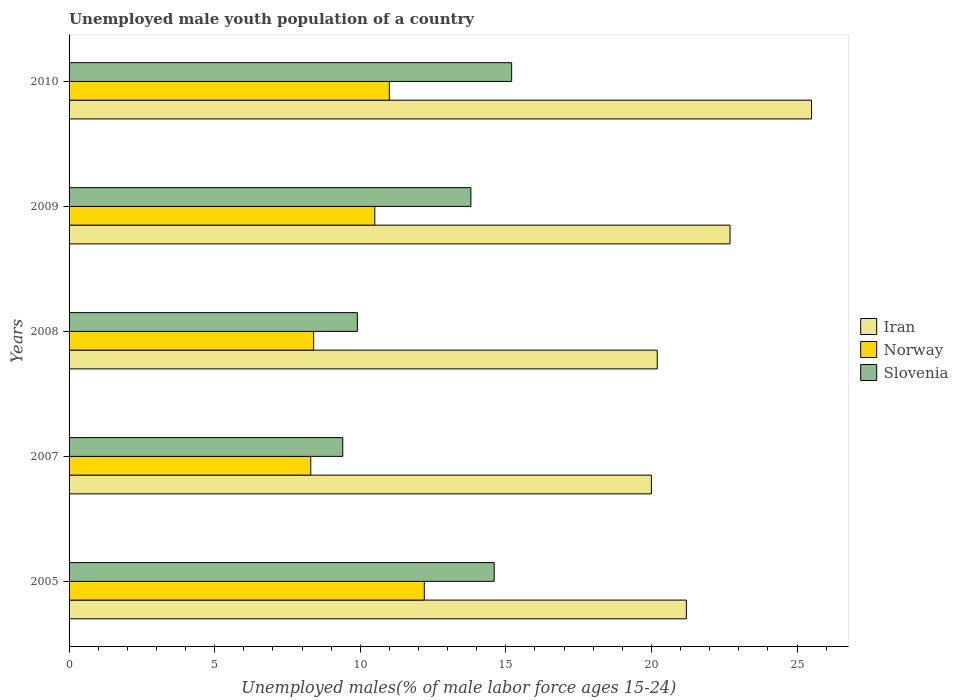How many different coloured bars are there?
Offer a very short reply. 3. How many groups of bars are there?
Provide a succinct answer. 5. Are the number of bars per tick equal to the number of legend labels?
Provide a succinct answer. Yes. How many bars are there on the 4th tick from the bottom?
Make the answer very short. 3. What is the percentage of unemployed male youth population in Iran in 2005?
Offer a very short reply. 21.2. Across all years, what is the maximum percentage of unemployed male youth population in Norway?
Offer a terse response. 12.2. Across all years, what is the minimum percentage of unemployed male youth population in Norway?
Offer a terse response. 8.3. In which year was the percentage of unemployed male youth population in Slovenia maximum?
Provide a short and direct response. 2010. In which year was the percentage of unemployed male youth population in Iran minimum?
Keep it short and to the point. 2007. What is the total percentage of unemployed male youth population in Norway in the graph?
Ensure brevity in your answer.  50.4. What is the difference between the percentage of unemployed male youth population in Slovenia in 2005 and that in 2009?
Ensure brevity in your answer.  0.8. What is the difference between the percentage of unemployed male youth population in Slovenia in 2008 and the percentage of unemployed male youth population in Norway in 2007?
Give a very brief answer. 1.6. What is the average percentage of unemployed male youth population in Slovenia per year?
Keep it short and to the point. 12.58. In the year 2010, what is the difference between the percentage of unemployed male youth population in Slovenia and percentage of unemployed male youth population in Iran?
Provide a short and direct response. -10.3. What is the ratio of the percentage of unemployed male youth population in Norway in 2007 to that in 2008?
Make the answer very short. 0.99. Is the difference between the percentage of unemployed male youth population in Slovenia in 2008 and 2009 greater than the difference between the percentage of unemployed male youth population in Iran in 2008 and 2009?
Your answer should be compact. No. What is the difference between the highest and the second highest percentage of unemployed male youth population in Norway?
Make the answer very short. 1.2. What is the difference between the highest and the lowest percentage of unemployed male youth population in Slovenia?
Keep it short and to the point. 5.8. In how many years, is the percentage of unemployed male youth population in Slovenia greater than the average percentage of unemployed male youth population in Slovenia taken over all years?
Ensure brevity in your answer.  3. What does the 3rd bar from the top in 2010 represents?
Keep it short and to the point. Iran. What does the 1st bar from the bottom in 2005 represents?
Provide a short and direct response. Iran. Is it the case that in every year, the sum of the percentage of unemployed male youth population in Norway and percentage of unemployed male youth population in Iran is greater than the percentage of unemployed male youth population in Slovenia?
Your response must be concise. Yes. What is the difference between two consecutive major ticks on the X-axis?
Your answer should be compact. 5. Are the values on the major ticks of X-axis written in scientific E-notation?
Your answer should be very brief. No. Does the graph contain any zero values?
Keep it short and to the point. No. How many legend labels are there?
Offer a very short reply. 3. How are the legend labels stacked?
Provide a succinct answer. Vertical. What is the title of the graph?
Provide a succinct answer. Unemployed male youth population of a country. What is the label or title of the X-axis?
Provide a succinct answer. Unemployed males(% of male labor force ages 15-24). What is the label or title of the Y-axis?
Your response must be concise. Years. What is the Unemployed males(% of male labor force ages 15-24) of Iran in 2005?
Make the answer very short. 21.2. What is the Unemployed males(% of male labor force ages 15-24) of Norway in 2005?
Make the answer very short. 12.2. What is the Unemployed males(% of male labor force ages 15-24) in Slovenia in 2005?
Give a very brief answer. 14.6. What is the Unemployed males(% of male labor force ages 15-24) in Iran in 2007?
Make the answer very short. 20. What is the Unemployed males(% of male labor force ages 15-24) of Norway in 2007?
Ensure brevity in your answer.  8.3. What is the Unemployed males(% of male labor force ages 15-24) in Slovenia in 2007?
Your response must be concise. 9.4. What is the Unemployed males(% of male labor force ages 15-24) of Iran in 2008?
Your answer should be compact. 20.2. What is the Unemployed males(% of male labor force ages 15-24) in Norway in 2008?
Keep it short and to the point. 8.4. What is the Unemployed males(% of male labor force ages 15-24) of Slovenia in 2008?
Ensure brevity in your answer.  9.9. What is the Unemployed males(% of male labor force ages 15-24) in Iran in 2009?
Offer a very short reply. 22.7. What is the Unemployed males(% of male labor force ages 15-24) in Norway in 2009?
Keep it short and to the point. 10.5. What is the Unemployed males(% of male labor force ages 15-24) in Slovenia in 2009?
Your response must be concise. 13.8. What is the Unemployed males(% of male labor force ages 15-24) of Norway in 2010?
Give a very brief answer. 11. What is the Unemployed males(% of male labor force ages 15-24) in Slovenia in 2010?
Give a very brief answer. 15.2. Across all years, what is the maximum Unemployed males(% of male labor force ages 15-24) in Iran?
Your response must be concise. 25.5. Across all years, what is the maximum Unemployed males(% of male labor force ages 15-24) in Norway?
Your answer should be compact. 12.2. Across all years, what is the maximum Unemployed males(% of male labor force ages 15-24) of Slovenia?
Your answer should be compact. 15.2. Across all years, what is the minimum Unemployed males(% of male labor force ages 15-24) of Norway?
Offer a terse response. 8.3. Across all years, what is the minimum Unemployed males(% of male labor force ages 15-24) in Slovenia?
Provide a short and direct response. 9.4. What is the total Unemployed males(% of male labor force ages 15-24) in Iran in the graph?
Keep it short and to the point. 109.6. What is the total Unemployed males(% of male labor force ages 15-24) in Norway in the graph?
Your response must be concise. 50.4. What is the total Unemployed males(% of male labor force ages 15-24) of Slovenia in the graph?
Your answer should be compact. 62.9. What is the difference between the Unemployed males(% of male labor force ages 15-24) in Iran in 2005 and that in 2007?
Make the answer very short. 1.2. What is the difference between the Unemployed males(% of male labor force ages 15-24) in Slovenia in 2005 and that in 2007?
Your response must be concise. 5.2. What is the difference between the Unemployed males(% of male labor force ages 15-24) in Norway in 2005 and that in 2008?
Ensure brevity in your answer.  3.8. What is the difference between the Unemployed males(% of male labor force ages 15-24) of Slovenia in 2005 and that in 2008?
Offer a very short reply. 4.7. What is the difference between the Unemployed males(% of male labor force ages 15-24) of Norway in 2005 and that in 2009?
Your response must be concise. 1.7. What is the difference between the Unemployed males(% of male labor force ages 15-24) of Iran in 2005 and that in 2010?
Provide a succinct answer. -4.3. What is the difference between the Unemployed males(% of male labor force ages 15-24) in Norway in 2005 and that in 2010?
Offer a very short reply. 1.2. What is the difference between the Unemployed males(% of male labor force ages 15-24) in Slovenia in 2005 and that in 2010?
Keep it short and to the point. -0.6. What is the difference between the Unemployed males(% of male labor force ages 15-24) of Slovenia in 2007 and that in 2008?
Ensure brevity in your answer.  -0.5. What is the difference between the Unemployed males(% of male labor force ages 15-24) of Slovenia in 2007 and that in 2009?
Your response must be concise. -4.4. What is the difference between the Unemployed males(% of male labor force ages 15-24) of Iran in 2007 and that in 2010?
Keep it short and to the point. -5.5. What is the difference between the Unemployed males(% of male labor force ages 15-24) of Norway in 2007 and that in 2010?
Keep it short and to the point. -2.7. What is the difference between the Unemployed males(% of male labor force ages 15-24) of Slovenia in 2007 and that in 2010?
Provide a succinct answer. -5.8. What is the difference between the Unemployed males(% of male labor force ages 15-24) of Norway in 2008 and that in 2009?
Give a very brief answer. -2.1. What is the difference between the Unemployed males(% of male labor force ages 15-24) in Slovenia in 2008 and that in 2009?
Provide a short and direct response. -3.9. What is the difference between the Unemployed males(% of male labor force ages 15-24) in Slovenia in 2009 and that in 2010?
Your response must be concise. -1.4. What is the difference between the Unemployed males(% of male labor force ages 15-24) in Iran in 2005 and the Unemployed males(% of male labor force ages 15-24) in Norway in 2007?
Your answer should be compact. 12.9. What is the difference between the Unemployed males(% of male labor force ages 15-24) of Norway in 2005 and the Unemployed males(% of male labor force ages 15-24) of Slovenia in 2007?
Your answer should be compact. 2.8. What is the difference between the Unemployed males(% of male labor force ages 15-24) of Iran in 2005 and the Unemployed males(% of male labor force ages 15-24) of Norway in 2008?
Provide a succinct answer. 12.8. What is the difference between the Unemployed males(% of male labor force ages 15-24) of Iran in 2005 and the Unemployed males(% of male labor force ages 15-24) of Norway in 2009?
Provide a short and direct response. 10.7. What is the difference between the Unemployed males(% of male labor force ages 15-24) in Norway in 2005 and the Unemployed males(% of male labor force ages 15-24) in Slovenia in 2010?
Ensure brevity in your answer.  -3. What is the difference between the Unemployed males(% of male labor force ages 15-24) in Iran in 2007 and the Unemployed males(% of male labor force ages 15-24) in Norway in 2008?
Provide a short and direct response. 11.6. What is the difference between the Unemployed males(% of male labor force ages 15-24) in Iran in 2007 and the Unemployed males(% of male labor force ages 15-24) in Slovenia in 2008?
Make the answer very short. 10.1. What is the difference between the Unemployed males(% of male labor force ages 15-24) in Norway in 2007 and the Unemployed males(% of male labor force ages 15-24) in Slovenia in 2008?
Your answer should be compact. -1.6. What is the difference between the Unemployed males(% of male labor force ages 15-24) in Iran in 2007 and the Unemployed males(% of male labor force ages 15-24) in Norway in 2009?
Your answer should be very brief. 9.5. What is the difference between the Unemployed males(% of male labor force ages 15-24) of Iran in 2007 and the Unemployed males(% of male labor force ages 15-24) of Norway in 2010?
Make the answer very short. 9. What is the difference between the Unemployed males(% of male labor force ages 15-24) in Norway in 2007 and the Unemployed males(% of male labor force ages 15-24) in Slovenia in 2010?
Offer a terse response. -6.9. What is the difference between the Unemployed males(% of male labor force ages 15-24) in Iran in 2008 and the Unemployed males(% of male labor force ages 15-24) in Norway in 2009?
Provide a short and direct response. 9.7. What is the difference between the Unemployed males(% of male labor force ages 15-24) in Iran in 2008 and the Unemployed males(% of male labor force ages 15-24) in Slovenia in 2009?
Provide a succinct answer. 6.4. What is the difference between the Unemployed males(% of male labor force ages 15-24) in Iran in 2008 and the Unemployed males(% of male labor force ages 15-24) in Slovenia in 2010?
Ensure brevity in your answer.  5. What is the difference between the Unemployed males(% of male labor force ages 15-24) of Norway in 2008 and the Unemployed males(% of male labor force ages 15-24) of Slovenia in 2010?
Your answer should be very brief. -6.8. What is the difference between the Unemployed males(% of male labor force ages 15-24) of Norway in 2009 and the Unemployed males(% of male labor force ages 15-24) of Slovenia in 2010?
Keep it short and to the point. -4.7. What is the average Unemployed males(% of male labor force ages 15-24) of Iran per year?
Give a very brief answer. 21.92. What is the average Unemployed males(% of male labor force ages 15-24) of Norway per year?
Your response must be concise. 10.08. What is the average Unemployed males(% of male labor force ages 15-24) in Slovenia per year?
Offer a very short reply. 12.58. In the year 2007, what is the difference between the Unemployed males(% of male labor force ages 15-24) of Iran and Unemployed males(% of male labor force ages 15-24) of Norway?
Ensure brevity in your answer.  11.7. In the year 2008, what is the difference between the Unemployed males(% of male labor force ages 15-24) in Iran and Unemployed males(% of male labor force ages 15-24) in Norway?
Offer a terse response. 11.8. In the year 2008, what is the difference between the Unemployed males(% of male labor force ages 15-24) of Iran and Unemployed males(% of male labor force ages 15-24) of Slovenia?
Your answer should be very brief. 10.3. In the year 2009, what is the difference between the Unemployed males(% of male labor force ages 15-24) in Iran and Unemployed males(% of male labor force ages 15-24) in Slovenia?
Make the answer very short. 8.9. In the year 2009, what is the difference between the Unemployed males(% of male labor force ages 15-24) of Norway and Unemployed males(% of male labor force ages 15-24) of Slovenia?
Ensure brevity in your answer.  -3.3. What is the ratio of the Unemployed males(% of male labor force ages 15-24) in Iran in 2005 to that in 2007?
Offer a terse response. 1.06. What is the ratio of the Unemployed males(% of male labor force ages 15-24) of Norway in 2005 to that in 2007?
Keep it short and to the point. 1.47. What is the ratio of the Unemployed males(% of male labor force ages 15-24) in Slovenia in 2005 to that in 2007?
Provide a succinct answer. 1.55. What is the ratio of the Unemployed males(% of male labor force ages 15-24) of Iran in 2005 to that in 2008?
Your response must be concise. 1.05. What is the ratio of the Unemployed males(% of male labor force ages 15-24) of Norway in 2005 to that in 2008?
Offer a very short reply. 1.45. What is the ratio of the Unemployed males(% of male labor force ages 15-24) in Slovenia in 2005 to that in 2008?
Keep it short and to the point. 1.47. What is the ratio of the Unemployed males(% of male labor force ages 15-24) of Iran in 2005 to that in 2009?
Keep it short and to the point. 0.93. What is the ratio of the Unemployed males(% of male labor force ages 15-24) of Norway in 2005 to that in 2009?
Keep it short and to the point. 1.16. What is the ratio of the Unemployed males(% of male labor force ages 15-24) in Slovenia in 2005 to that in 2009?
Provide a short and direct response. 1.06. What is the ratio of the Unemployed males(% of male labor force ages 15-24) of Iran in 2005 to that in 2010?
Provide a succinct answer. 0.83. What is the ratio of the Unemployed males(% of male labor force ages 15-24) in Norway in 2005 to that in 2010?
Offer a terse response. 1.11. What is the ratio of the Unemployed males(% of male labor force ages 15-24) in Slovenia in 2005 to that in 2010?
Your answer should be very brief. 0.96. What is the ratio of the Unemployed males(% of male labor force ages 15-24) of Iran in 2007 to that in 2008?
Give a very brief answer. 0.99. What is the ratio of the Unemployed males(% of male labor force ages 15-24) of Slovenia in 2007 to that in 2008?
Ensure brevity in your answer.  0.95. What is the ratio of the Unemployed males(% of male labor force ages 15-24) in Iran in 2007 to that in 2009?
Your answer should be compact. 0.88. What is the ratio of the Unemployed males(% of male labor force ages 15-24) in Norway in 2007 to that in 2009?
Offer a very short reply. 0.79. What is the ratio of the Unemployed males(% of male labor force ages 15-24) of Slovenia in 2007 to that in 2009?
Your response must be concise. 0.68. What is the ratio of the Unemployed males(% of male labor force ages 15-24) in Iran in 2007 to that in 2010?
Your response must be concise. 0.78. What is the ratio of the Unemployed males(% of male labor force ages 15-24) in Norway in 2007 to that in 2010?
Your response must be concise. 0.75. What is the ratio of the Unemployed males(% of male labor force ages 15-24) of Slovenia in 2007 to that in 2010?
Offer a very short reply. 0.62. What is the ratio of the Unemployed males(% of male labor force ages 15-24) of Iran in 2008 to that in 2009?
Provide a short and direct response. 0.89. What is the ratio of the Unemployed males(% of male labor force ages 15-24) in Slovenia in 2008 to that in 2009?
Provide a succinct answer. 0.72. What is the ratio of the Unemployed males(% of male labor force ages 15-24) of Iran in 2008 to that in 2010?
Provide a succinct answer. 0.79. What is the ratio of the Unemployed males(% of male labor force ages 15-24) of Norway in 2008 to that in 2010?
Offer a terse response. 0.76. What is the ratio of the Unemployed males(% of male labor force ages 15-24) in Slovenia in 2008 to that in 2010?
Offer a very short reply. 0.65. What is the ratio of the Unemployed males(% of male labor force ages 15-24) in Iran in 2009 to that in 2010?
Offer a very short reply. 0.89. What is the ratio of the Unemployed males(% of male labor force ages 15-24) of Norway in 2009 to that in 2010?
Keep it short and to the point. 0.95. What is the ratio of the Unemployed males(% of male labor force ages 15-24) in Slovenia in 2009 to that in 2010?
Offer a very short reply. 0.91. What is the difference between the highest and the second highest Unemployed males(% of male labor force ages 15-24) of Iran?
Give a very brief answer. 2.8. What is the difference between the highest and the second highest Unemployed males(% of male labor force ages 15-24) of Slovenia?
Your answer should be compact. 0.6. What is the difference between the highest and the lowest Unemployed males(% of male labor force ages 15-24) in Iran?
Keep it short and to the point. 5.5. What is the difference between the highest and the lowest Unemployed males(% of male labor force ages 15-24) in Norway?
Make the answer very short. 3.9. 